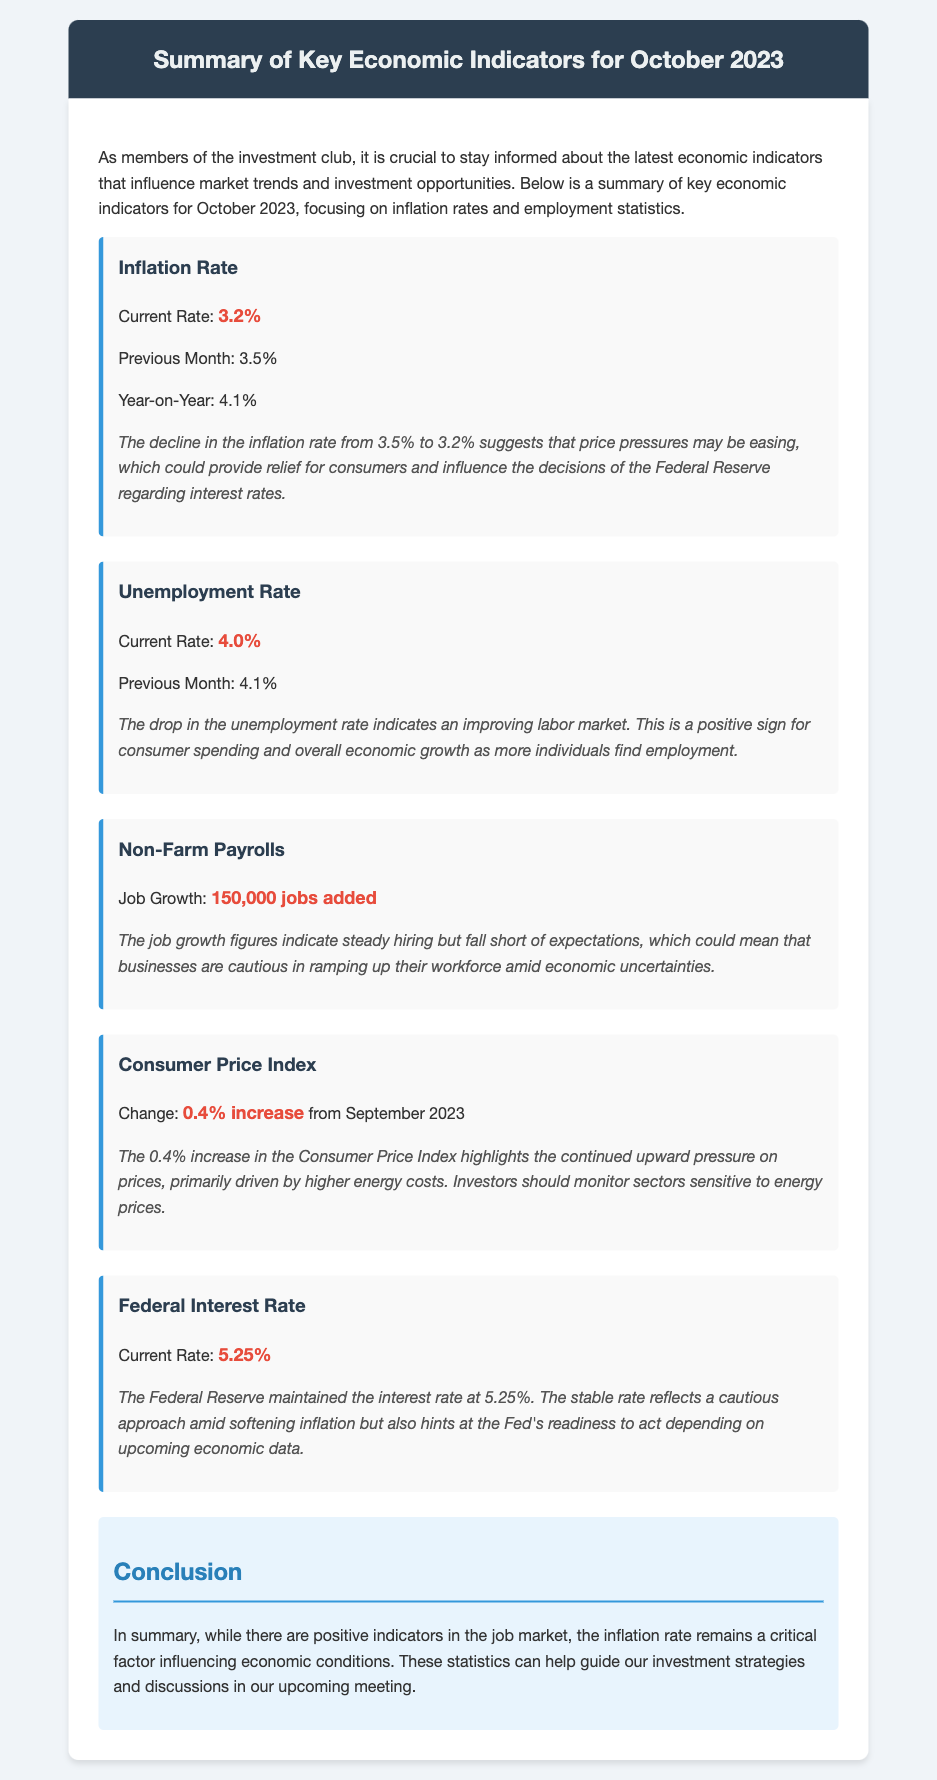What is the current inflation rate? The current inflation rate is stated directly in the document as 3.2%.
Answer: 3.2% What was the unemployment rate last month? The document mentions the unemployment rate for the previous month was 4.1%.
Answer: 4.1% How many jobs were added according to Non-Farm Payrolls? The document specifies that 150,000 jobs were added according to the Non-Farm Payrolls.
Answer: 150,000 jobs What is the current Federal Interest Rate? The document indicates that the current Federal Interest Rate is 5.25%.
Answer: 5.25% What does a decline in the inflation rate suggest? The analysis suggests that a decline in the inflation rate indicates that price pressures may be easing.
Answer: Price pressures may be easing What does the drop in the unemployment rate indicate about the labor market? The document indicates that the drop in the unemployment rate suggests an improving labor market.
Answer: Improving labor market What was the change in the Consumer Price Index from September 2023? The change in the Consumer Price Index is noted as a 0.4% increase from September 2023.
Answer: 0.4% increase What is a key factor influencing economic conditions according to the conclusion? The conclusion states that the inflation rate remains a critical factor influencing economic conditions.
Answer: Inflation rate What should investors monitor according to the analysis of the Consumer Price Index? Investors should monitor sectors sensitive to energy prices according to the analysis.
Answer: Sectors sensitive to energy prices 